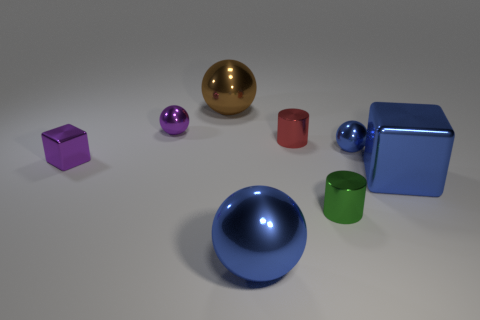Are there the same number of red cylinders right of the blue block and brown objects on the right side of the tiny green metal thing?
Give a very brief answer. Yes. There is a tiny cylinder that is behind the big metal thing that is right of the tiny metallic cylinder to the left of the small green metallic cylinder; what is its material?
Your answer should be very brief. Metal. There is a metal thing that is left of the brown ball and behind the small purple shiny block; what size is it?
Give a very brief answer. Small. Is the shape of the big brown metal thing the same as the red object?
Offer a very short reply. No. What is the shape of the brown object that is the same material as the blue cube?
Offer a terse response. Sphere. How many tiny things are either gray balls or blue blocks?
Keep it short and to the point. 0. There is a purple shiny thing that is on the right side of the purple metallic block; is there a brown shiny sphere left of it?
Offer a terse response. No. Are any small brown rubber cylinders visible?
Ensure brevity in your answer.  No. What color is the small ball left of the small metallic cylinder behind the blue block?
Ensure brevity in your answer.  Purple. There is another blue object that is the same shape as the small blue thing; what is it made of?
Make the answer very short. Metal. 